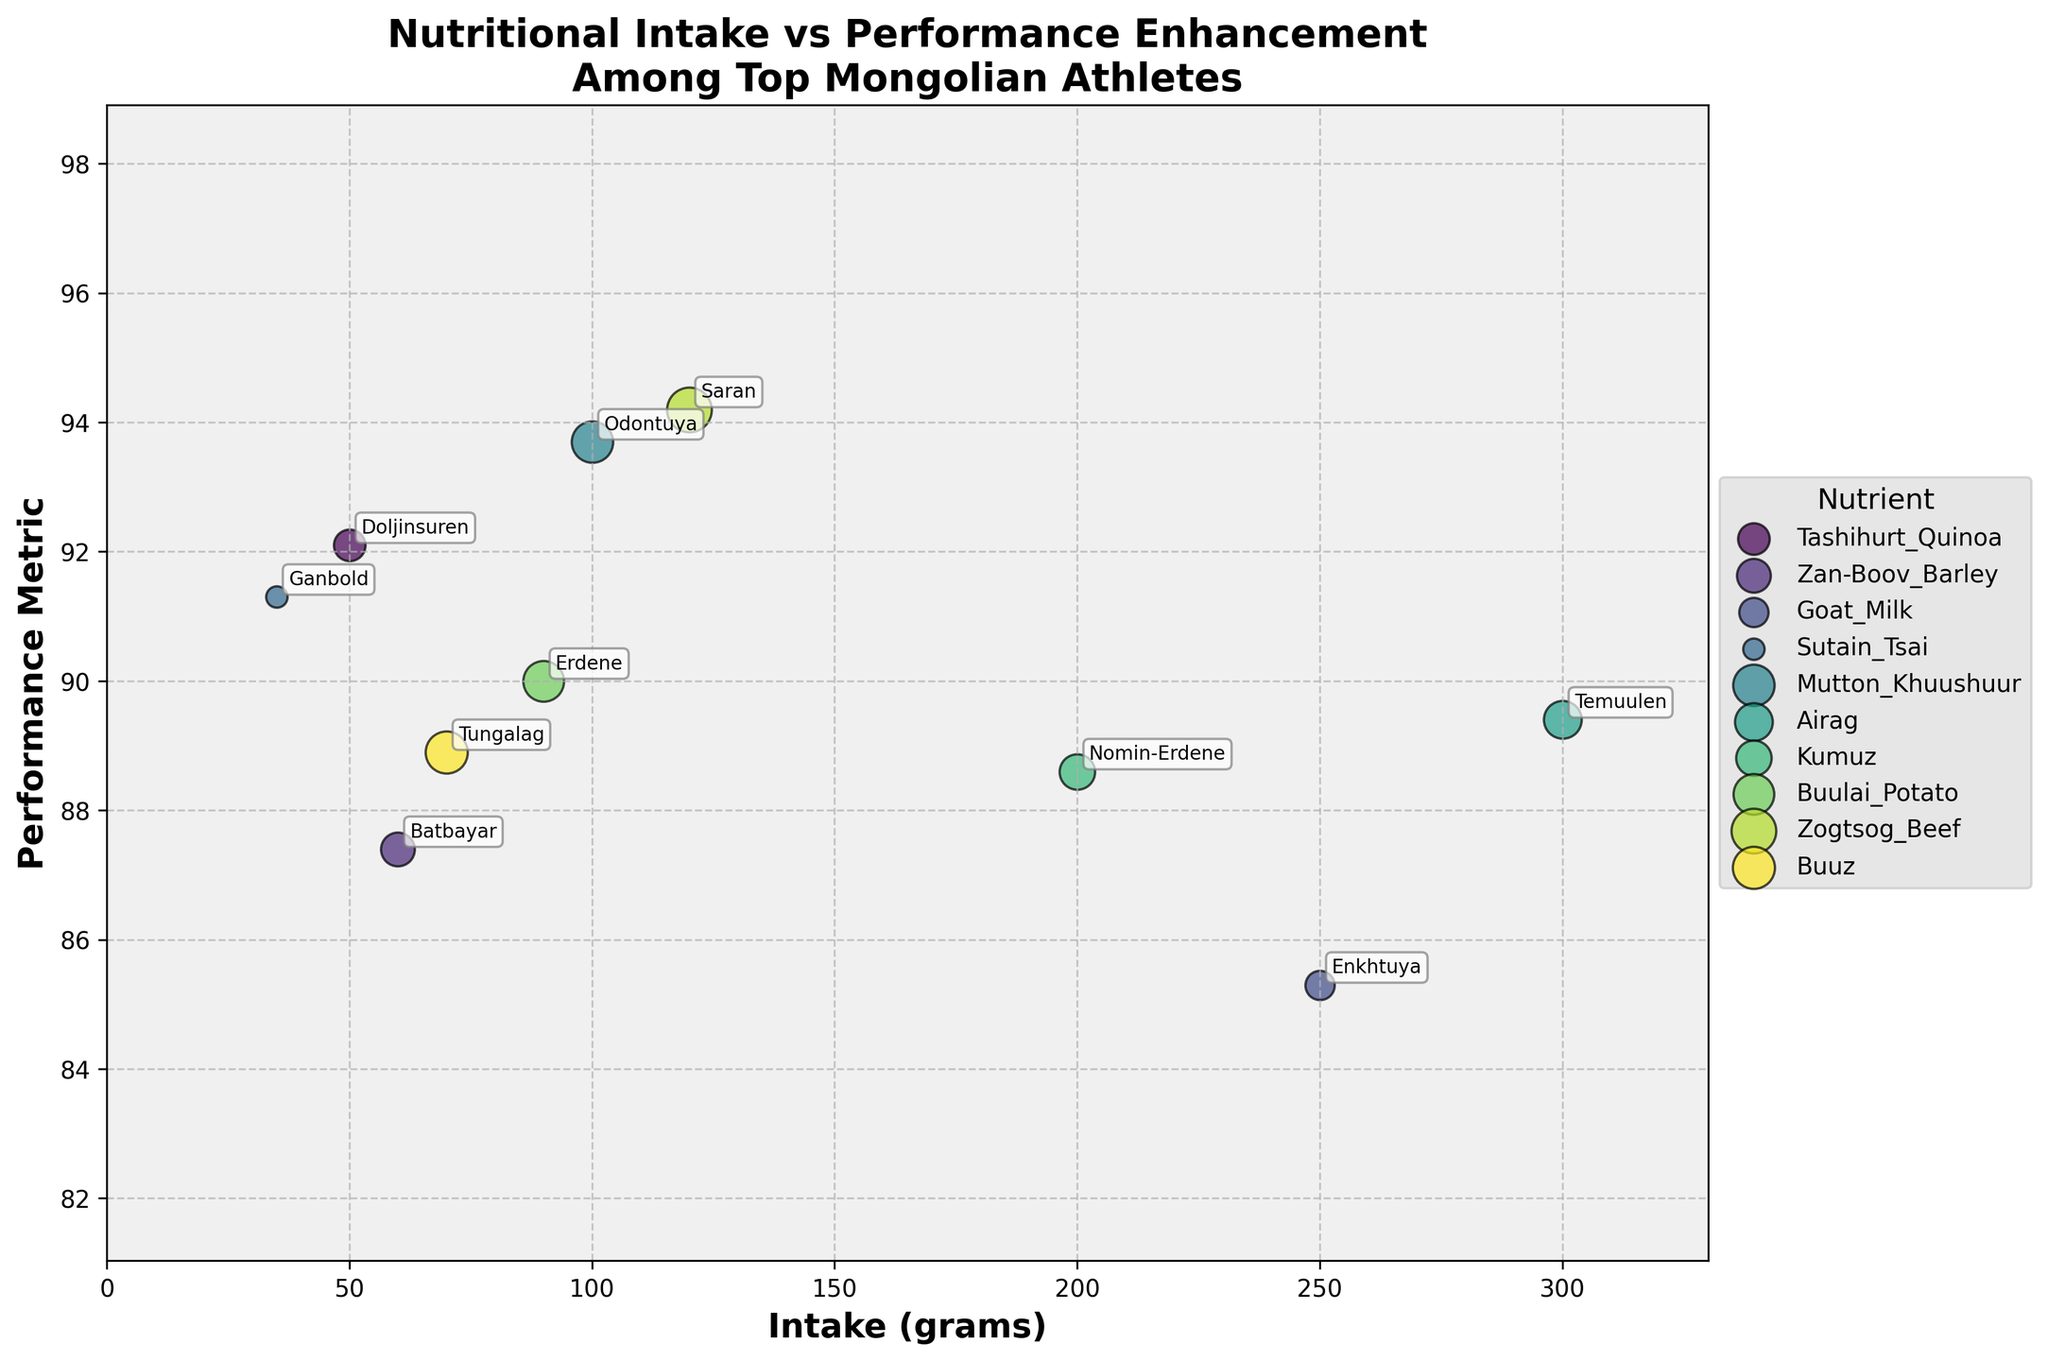What's the athlete with the highest performance metric? Look for the data point with the highest y-coordinate in the scatter plot. The highest performance metric is 94.2, which corresponds to the athlete Saran.
Answer: Saran What's the nutrient with the largest intake in grams? Check the x-axis and find the data point with the highest x-coordinate (Intake in grams). The maximum intake of 300 grams is associated with the nutrient Airag.
Answer: Airag Which athlete consumes the least calories daily? Look at the size of the scatter points and identify the smallest one, indicating the lowest daily calorie intake. Ganbold has the smallest point size with 80 calories.
Answer: Ganbold Among athletes consuming Mutton Khuushuur, what is the performance metric? Identify the scatter point labeled Mutton Khuushuur and check its y-coordinate value on the y-axis. The performance metric for Mutton Khuushuur is 93.7.
Answer: 93.7 What is the average performance metric for Goat Milk and Airag consumers? Locate the points for Goat Milk and Airag and note their y-coordinates (85.3 and 89.4). The average is calculated as (85.3 + 89.4) / 2 = 87.35.
Answer: 87.35 Which nutrient has the highest average performance metric among its consumers? Compare the performance metrics for each nutrient and calculate the average for each group. Saran with Zogtsog Beef has a 94.2 performance metric, which is higher than other groups.
Answer: Zogtsog Beef How does Doljinsuren’s performance compare to Odontuya’s? Locate the points for Doljinsuren (92.1) and Odontuya (93.7) and compare their y-coordinate values. Odontuya's performance metric of 93.7 is higher than Doljinsuren's 92.1.
Answer: Odontuya has a higher performance What’s the difference in grams of intake between Tungalag and Enkhtuya? Identify the intake in grams for Tungalag (70) and Enkhtuya (250), and calculate the difference: 250 - 70 = 180 grams.
Answer: 180 grams Which athlete has a performance metric closest to 90? Find the data point with a y-coordinate nearest to 90. Erdene with the performance metric of 90 is the closest.
Answer: Erdene Is there a correlation between daily calories and performance metrics among these athletes? Analyze the size of the points (representing daily calories) and their y-coordinate (performance metric). Although specific correlation calculations are not visible on the plot, a visual inspection shows no clear proportional relationship implying that calorie intake does not straightforwardly correlate with performance metrics.
Answer: No clear correlation 